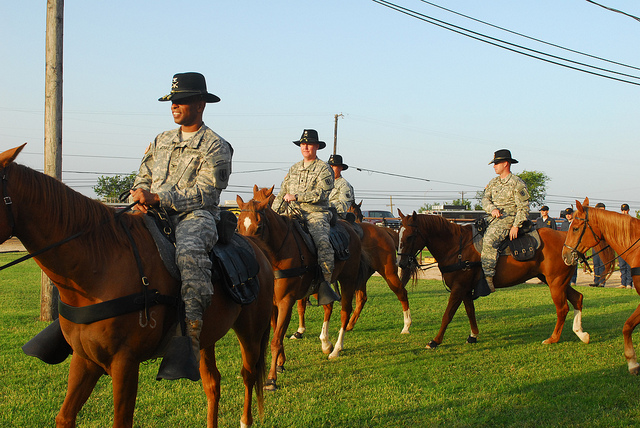Please transcribe the text information in this image. US US 